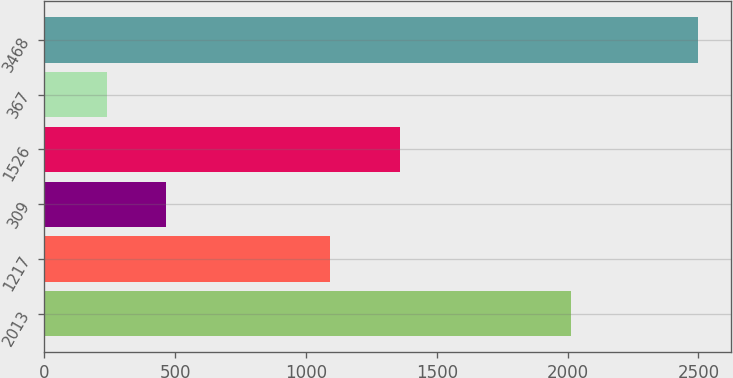<chart> <loc_0><loc_0><loc_500><loc_500><bar_chart><fcel>2013<fcel>1217<fcel>309<fcel>1526<fcel>367<fcel>3468<nl><fcel>2011<fcel>1093<fcel>465<fcel>1361<fcel>239<fcel>2499<nl></chart> 